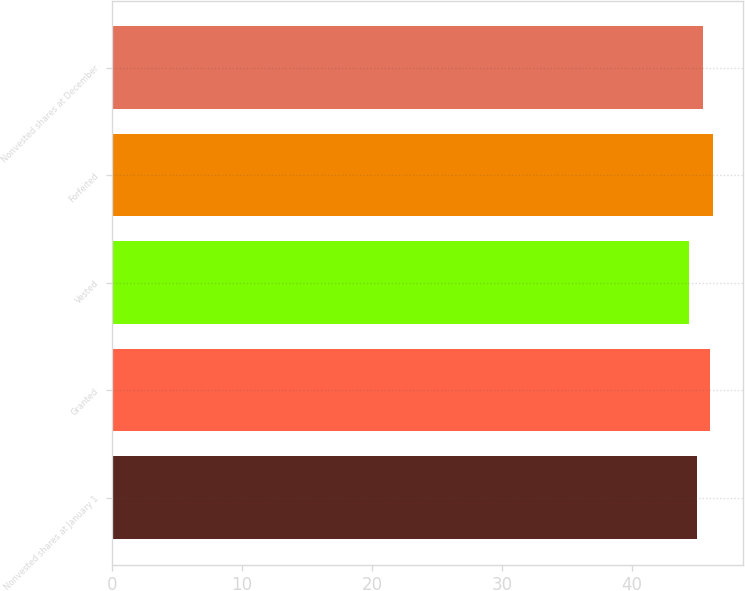<chart> <loc_0><loc_0><loc_500><loc_500><bar_chart><fcel>Nonvested shares at January 1<fcel>Granted<fcel>Vested<fcel>Forfeited<fcel>Nonvested shares at December<nl><fcel>44.96<fcel>45.99<fcel>44.4<fcel>46.25<fcel>45.42<nl></chart> 